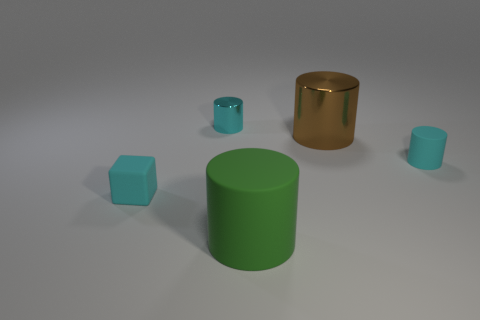The small object that is on the left side of the large brown cylinder and on the right side of the cube has what shape?
Your answer should be compact. Cylinder. What material is the cyan thing that is behind the tiny cylinder that is on the right side of the green thing?
Give a very brief answer. Metal. Are there more purple matte blocks than small rubber cylinders?
Your response must be concise. No. Does the tiny matte cylinder have the same color as the big metal object?
Provide a short and direct response. No. There is another thing that is the same size as the green thing; what is it made of?
Your answer should be very brief. Metal. Do the brown cylinder and the large green cylinder have the same material?
Keep it short and to the point. No. How many big green objects have the same material as the big green cylinder?
Keep it short and to the point. 0. How many things are either cyan cylinders on the right side of the small cyan metallic cylinder or cyan matte things that are on the left side of the big green matte object?
Ensure brevity in your answer.  2. Are there more big things that are in front of the large brown shiny cylinder than tiny cyan rubber objects to the right of the small cyan rubber cube?
Offer a very short reply. No. What color is the metallic thing that is to the left of the large brown cylinder?
Ensure brevity in your answer.  Cyan. 